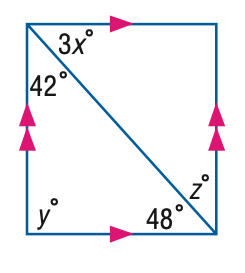Answer the mathemtical geometry problem and directly provide the correct option letter.
Question: Find z in the figure.
Choices: A: 16 B: 36 C: 42 D: 48 C 